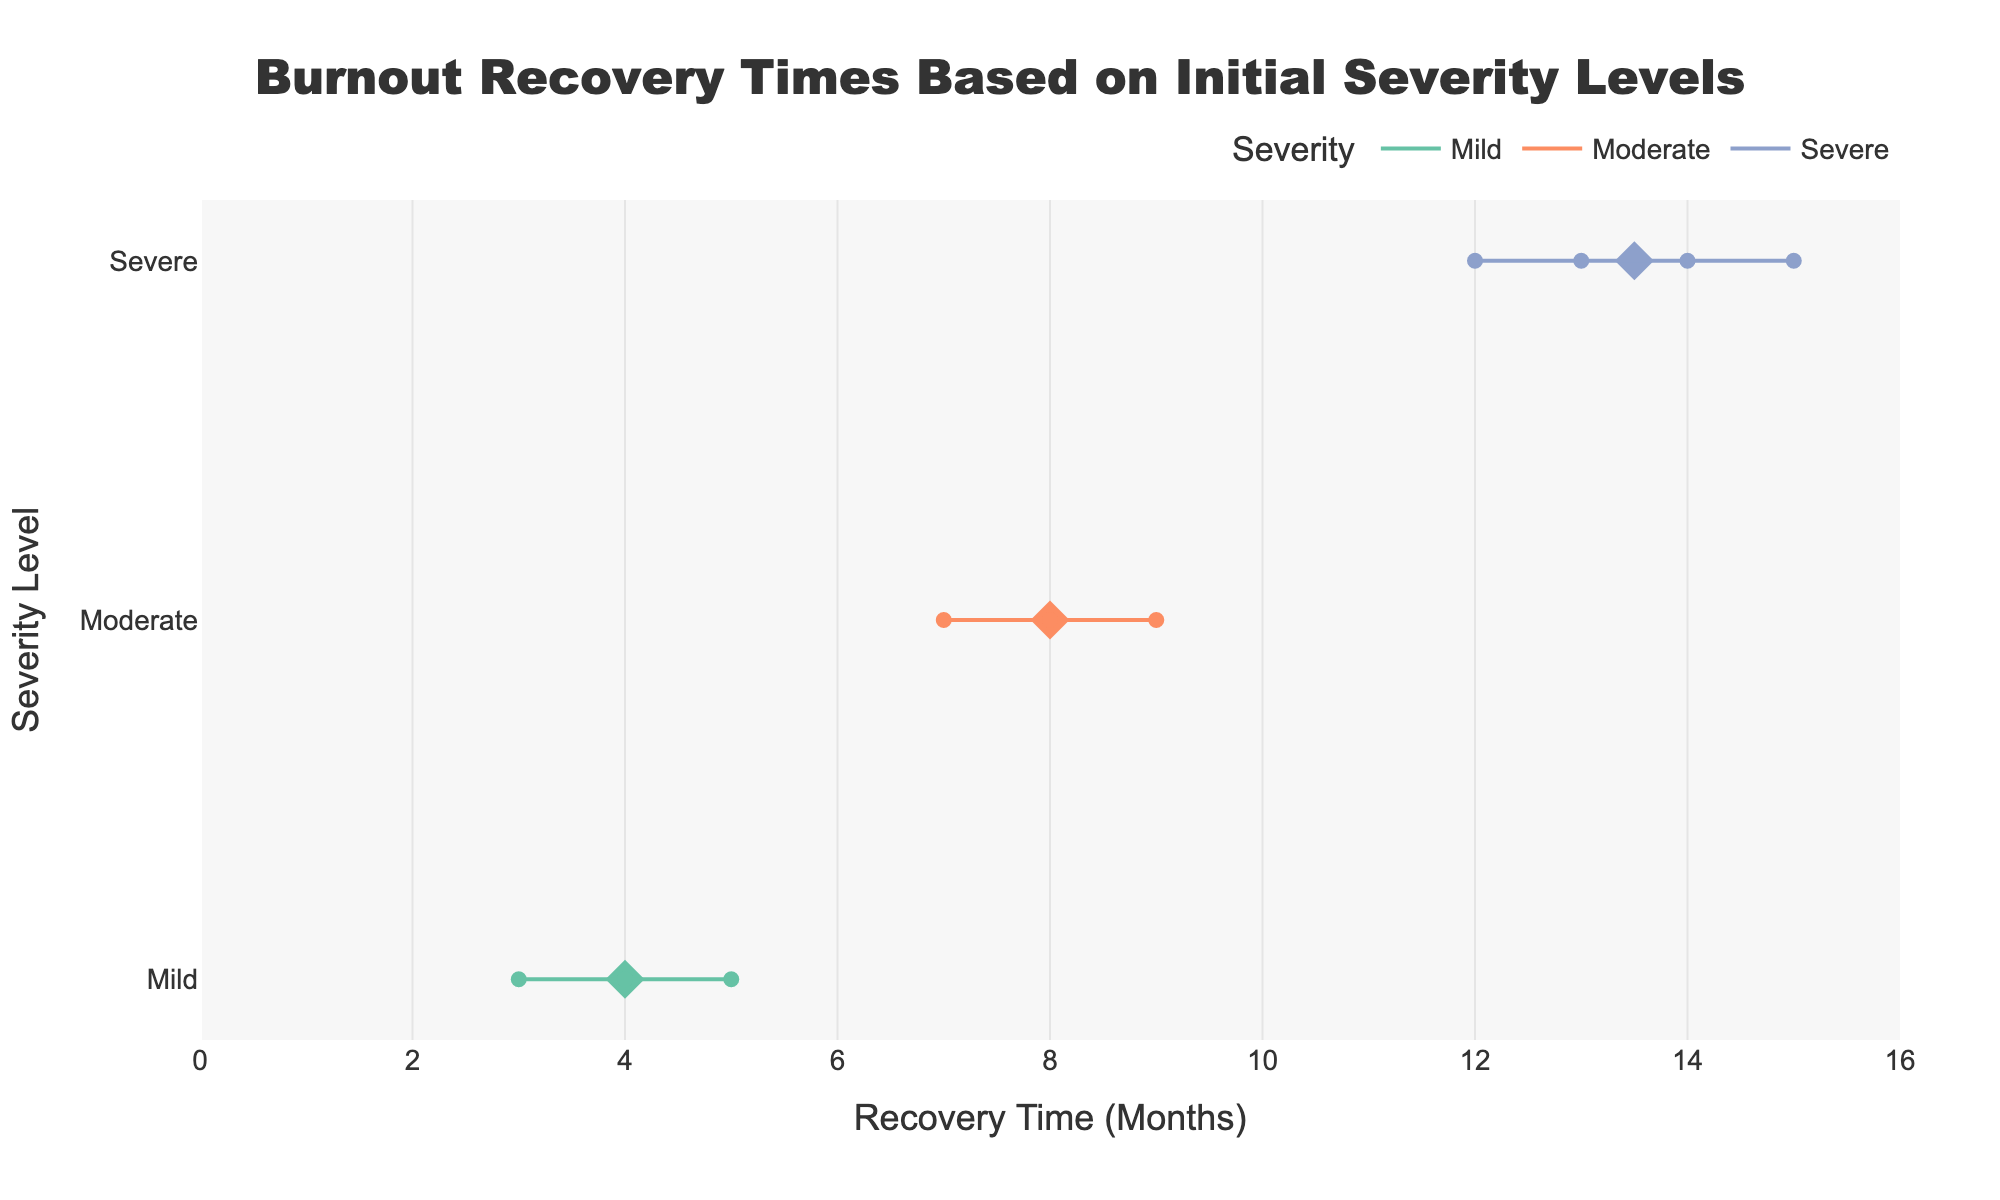How many severity levels are represented in the figure? There are three severity levels represented in the figure: Mild, Moderate, and Severe, as shown on the y-axis.
Answer: 3 What is the average recovery time for patients with Moderate severity? The average recovery time for patients with Moderate severity is represented by the diamond marker for the "Moderate" group, which is placed at approximately 8 months on the x-axis.
Answer: 8 months Which severity level has the longest range in recovery times? The Severe severity level has the longest range in recovery times, from 12 months to 15 months, as shown by the extent of the horizontal line for this group.
Answer: Severe What is the recovery time for Patient P003? Patient P003 is indicated by the hover text showing "Patient: P003," and their recovery time is 5 months. The hover text specifies this information.
Answer: 5 months Compare the mean recovery times between Mild and Severe severity levels. Which one is higher? The diamond marker for Mild severity is at approximately 4 months, while the diamond marker for Severe severity is at approximately 13.5 months. The mean recovery time for the Severe group is higher.
Answer: Severe What is the shortest recovery time recorded for the Severe severity level? The shortest recovery time for the Severe severity level is represented by the horizontal line's starting point, which is at 12 months.
Answer: 12 months How many patients in the Mild group received Cognitive Behavioral Therapy? In the hover information, there are two patients (P001 and P004) listed under the Mild group that received Cognitive Behavioral Therapy.
Answer: 2 Which severity group has a patient with the longest recovery time, and what is the duration? The Severe group has the patient with the longest recovery time, which is 15 months, as shown by the horizontal line ending at this point.
Answer: Severe, 15 months What is the range of recovery time for the Moderate severity level? For the Moderate severity level, the recovery time ranges from 7 months to 9 months, as shown by the extent of the horizontal line.
Answer: 7-9 months Among patients who did not receive any medication, which severity level has the longest recorded recovery time and what is it? The patient with the Severe severity level who did not receive medication has the longest recorded recovery time of 15 months, indicated by the hover text for EMDR therapy.
Answer: Severe, 15 months 